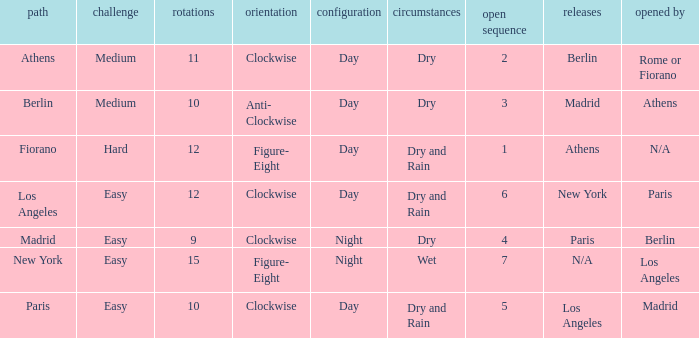What is the difficulty of the athens circuit? Medium. 